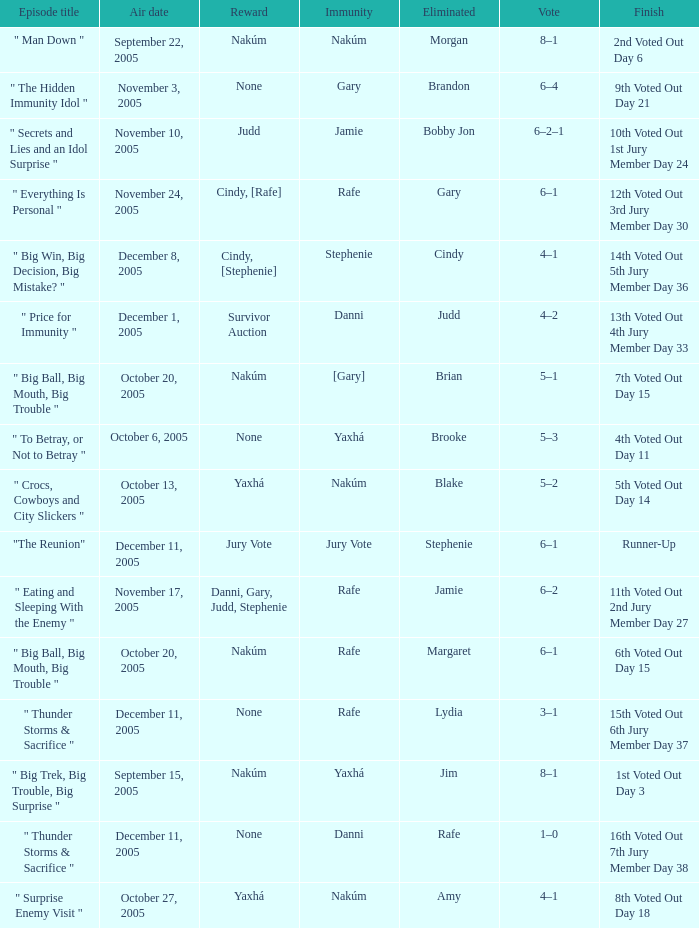How many rewards are there for air date October 6, 2005? None. 